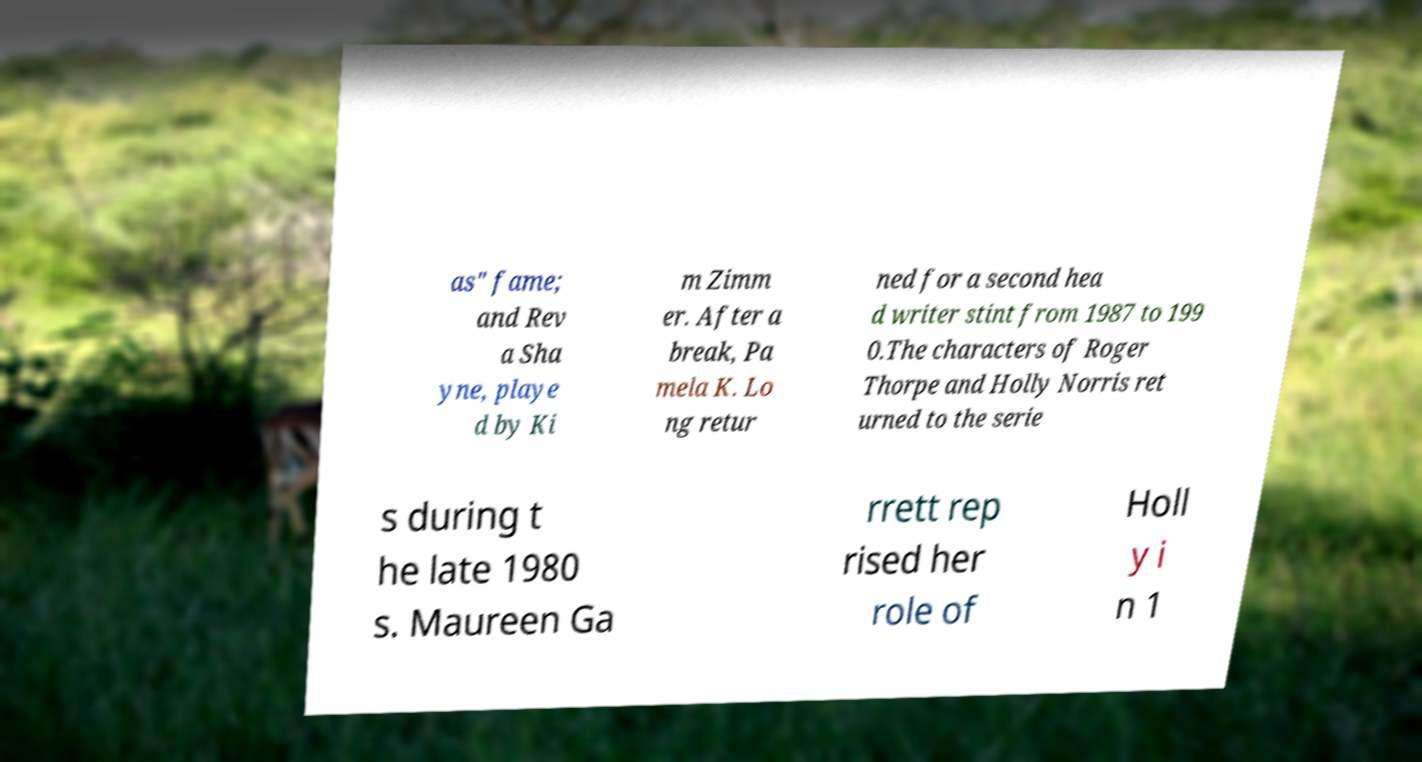Please identify and transcribe the text found in this image. as" fame; and Rev a Sha yne, playe d by Ki m Zimm er. After a break, Pa mela K. Lo ng retur ned for a second hea d writer stint from 1987 to 199 0.The characters of Roger Thorpe and Holly Norris ret urned to the serie s during t he late 1980 s. Maureen Ga rrett rep rised her role of Holl y i n 1 